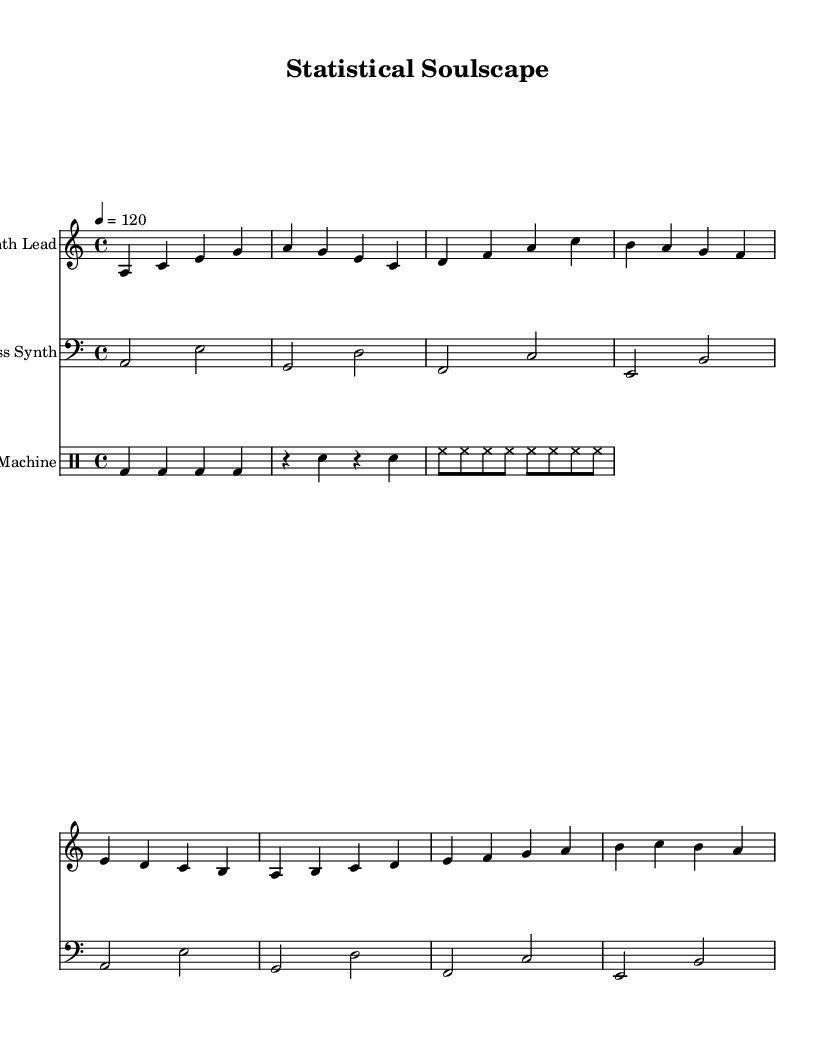What is the key signature of this music? The key signature indicates A minor, which has no sharps or flats. This can be determined by inspecting the key signature at the beginning of the staff.
Answer: A minor What is the time signature of this piece? The time signature is indicated as 4/4, which can be found after the key signature at the beginning of the score. It shows that there are four beats per measure and a quarter note gets one beat.
Answer: 4/4 What is the tempo marking for this composition? The tempo marking shows a beat of 120 BPM, noted in the score as "4 = 120". This indicates the speed of the music.
Answer: 120 How many measures are in the synth lead? The synth lead part contains eight measures, which can be counted directly by looking at the bar lines in the part labeled "Synth Lead".
Answer: 8 What type of percussion instrument is primarily used in the drum machine section? The primary percussion instrument here is a bass drum, as indicated by the use of "bd" in the drum notation throughout the sequence.
Answer: Bass drum Which melodic instrument is playing in a higher octave, the synth lead or the bass synth? The synth lead is in a higher octave, as it is written in the treble clef relative to the bass synth, which is in the bass clef.
Answer: Synth lead What rhythmic pattern is used for the hi-hat in the drum machine? The hi-hat is played in a steady eighth note pattern, with "hh" notation appearing in quick succession, indicating continuous play.
Answer: Eighth notes 